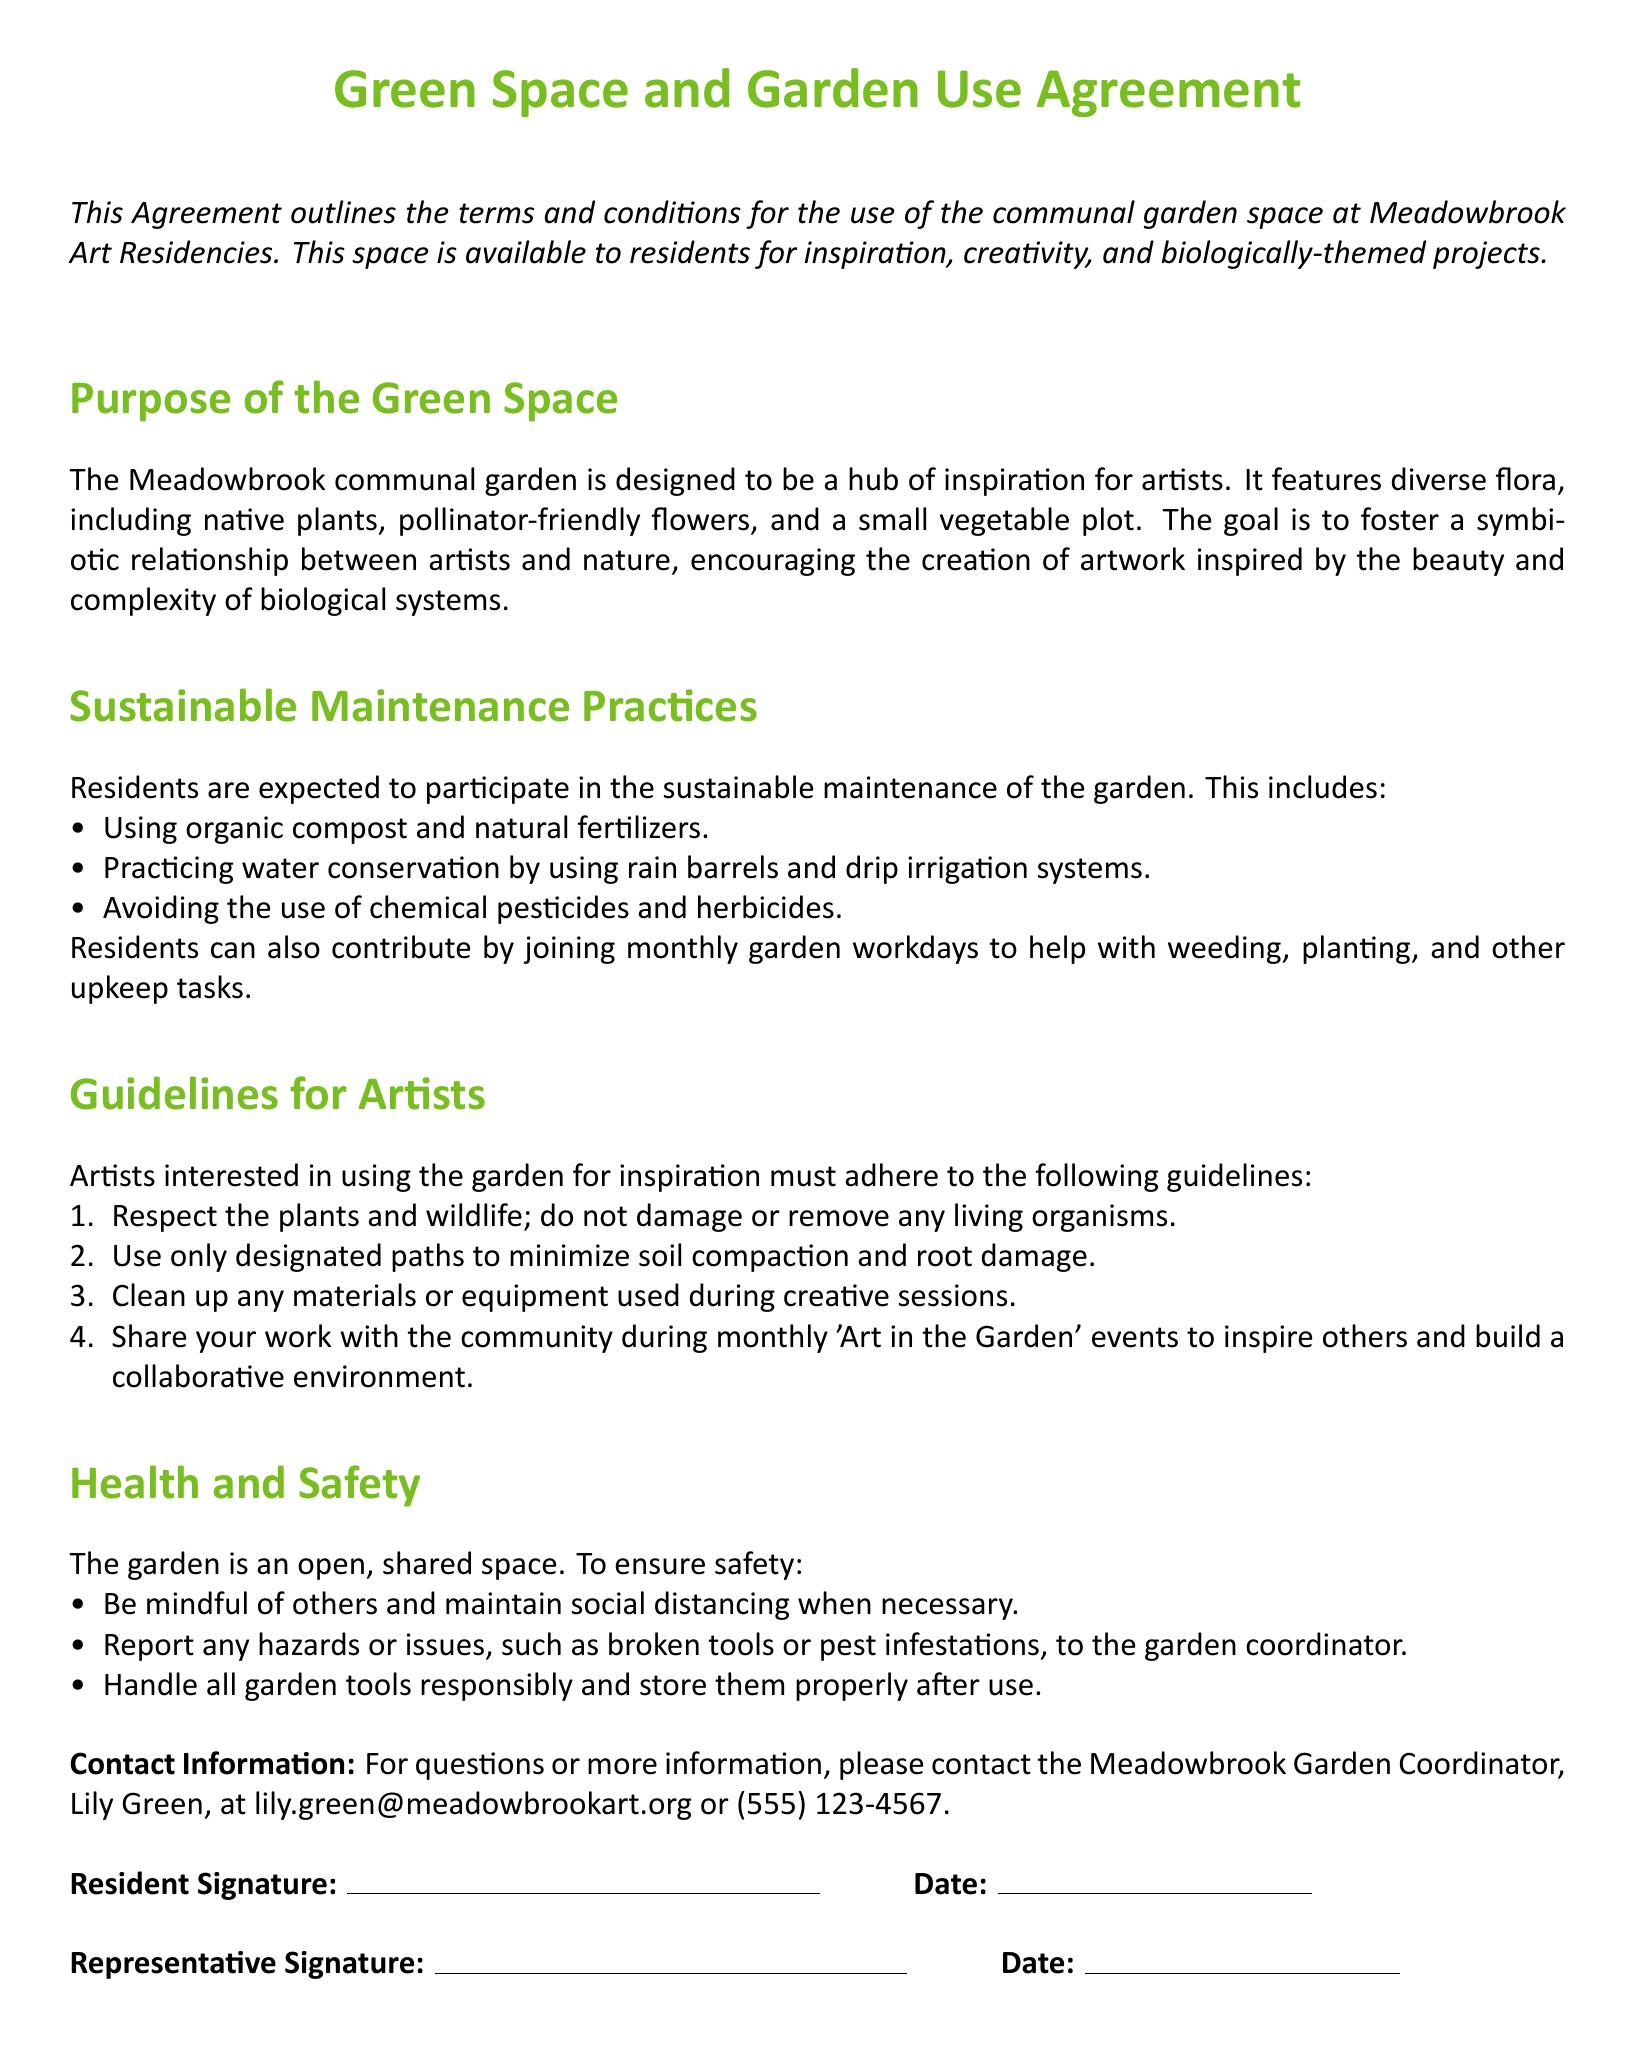What is the name of the garden coordinator? The garden coordinator is the person responsible for overseeing the garden and helping residents.
Answer: Lily Green What should residents use for garden maintenance? This asks for the materials that residents are expected to use in maintaining the garden per the sustainable maintenance practices.
Answer: Organic compost and natural fertilizers How often are the garden workdays scheduled? This question focuses on the frequency of participation expected from residents in maintaining the garden.
Answer: Monthly What type of plants are featured in the garden? The question seeks to identify the types of flora promoted in the garden.
Answer: Native plants, pollinator-friendly flowers, and a small vegetable plot How should artists handle the plants in the garden? This question requires understanding the respectful behavior expected from artists regarding the garden's flora.
Answer: Do not damage or remove any living organisms What is the purpose of the communal garden? This question inquires about the main intent behind having a shared garden space.
Answer: A hub of inspiration for artists What should artists do with their materials after using them? This question relates to the guidelines for artists in terms of cleanup responsibilities.
Answer: Clean up any materials or equipment What are artists encouraged to do during 'Art in the Garden' events? This question seeks to explore what is expected of artists during communal events held at the garden.
Answer: Share your work with the community 